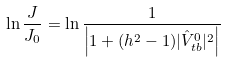Convert formula to latex. <formula><loc_0><loc_0><loc_500><loc_500>\ln \frac { J } { J _ { 0 } } = \ln \frac { 1 } { \left | 1 + ( h ^ { 2 } - 1 ) | \hat { V } _ { t b } ^ { 0 } | ^ { 2 } \right | }</formula> 